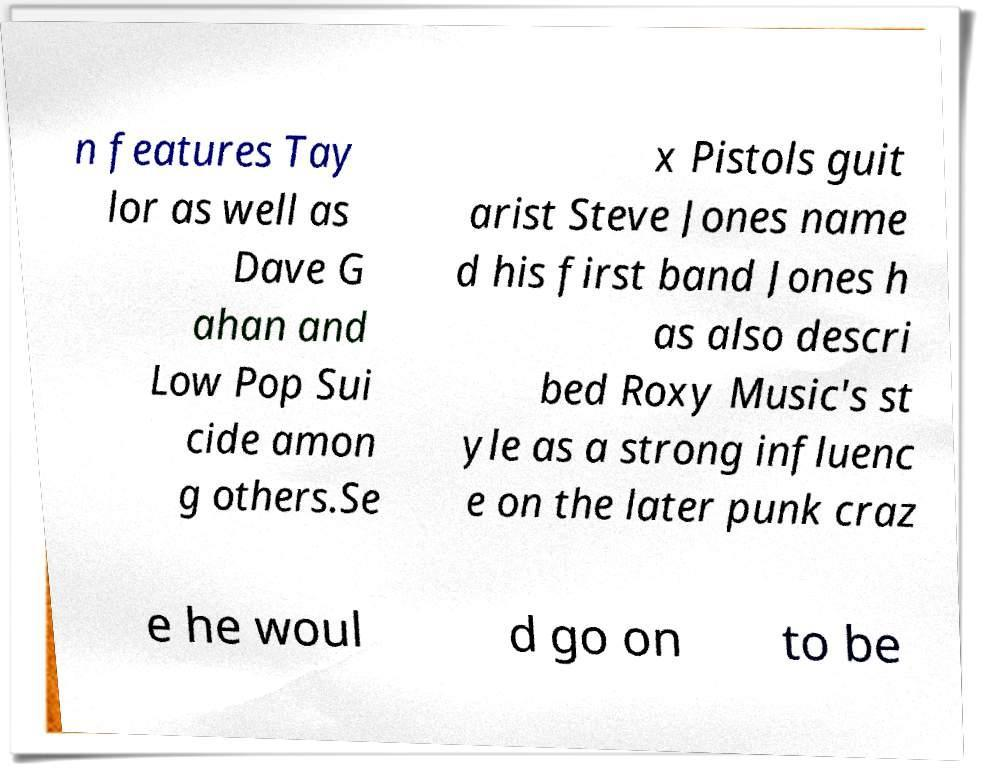For documentation purposes, I need the text within this image transcribed. Could you provide that? n features Tay lor as well as Dave G ahan and Low Pop Sui cide amon g others.Se x Pistols guit arist Steve Jones name d his first band Jones h as also descri bed Roxy Music's st yle as a strong influenc e on the later punk craz e he woul d go on to be 